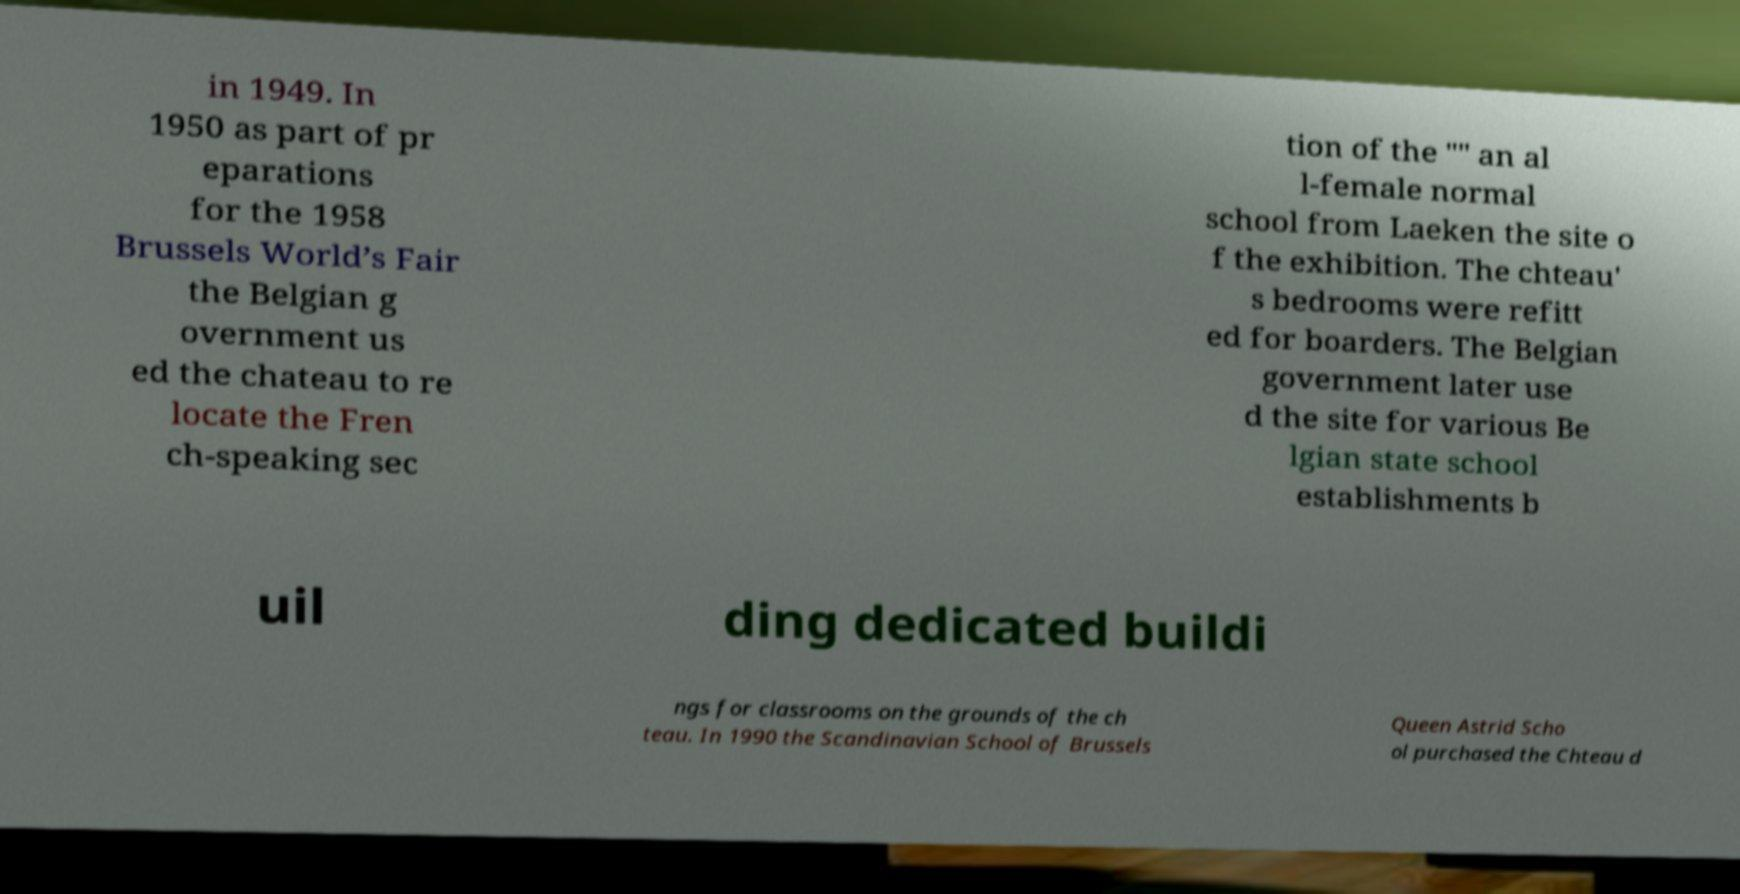For documentation purposes, I need the text within this image transcribed. Could you provide that? in 1949. In 1950 as part of pr eparations for the 1958 Brussels World’s Fair the Belgian g overnment us ed the chateau to re locate the Fren ch-speaking sec tion of the "" an al l-female normal school from Laeken the site o f the exhibition. The chteau' s bedrooms were refitt ed for boarders. The Belgian government later use d the site for various Be lgian state school establishments b uil ding dedicated buildi ngs for classrooms on the grounds of the ch teau. In 1990 the Scandinavian School of Brussels Queen Astrid Scho ol purchased the Chteau d 